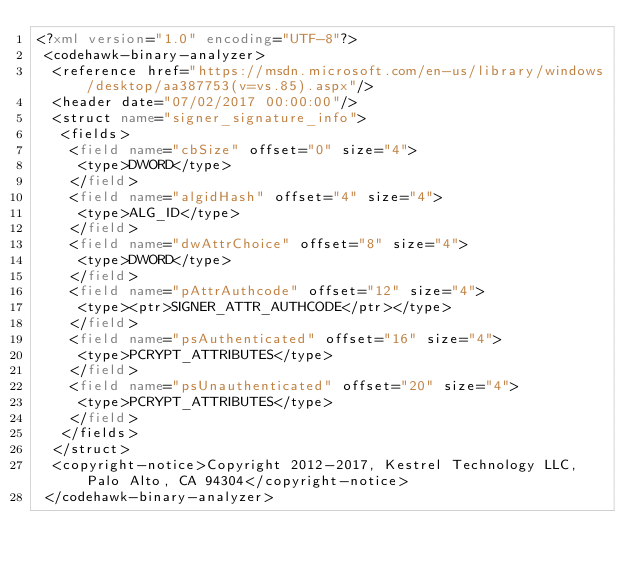Convert code to text. <code><loc_0><loc_0><loc_500><loc_500><_XML_><?xml version="1.0" encoding="UTF-8"?>
 <codehawk-binary-analyzer>
  <reference href="https://msdn.microsoft.com/en-us/library/windows/desktop/aa387753(v=vs.85).aspx"/>
  <header date="07/02/2017 00:00:00"/>
  <struct name="signer_signature_info">
   <fields>
    <field name="cbSize" offset="0" size="4">
     <type>DWORD</type>
    </field>
    <field name="algidHash" offset="4" size="4">
     <type>ALG_ID</type>
    </field>
    <field name="dwAttrChoice" offset="8" size="4">
     <type>DWORD</type>
    </field>
    <field name="pAttrAuthcode" offset="12" size="4">
     <type><ptr>SIGNER_ATTR_AUTHCODE</ptr></type>
    </field>
    <field name="psAuthenticated" offset="16" size="4">
     <type>PCRYPT_ATTRIBUTES</type>
    </field>
    <field name="psUnauthenticated" offset="20" size="4">
     <type>PCRYPT_ATTRIBUTES</type>
    </field>
   </fields>
  </struct>
  <copyright-notice>Copyright 2012-2017, Kestrel Technology LLC, Palo Alto, CA 94304</copyright-notice>
 </codehawk-binary-analyzer>
</code> 